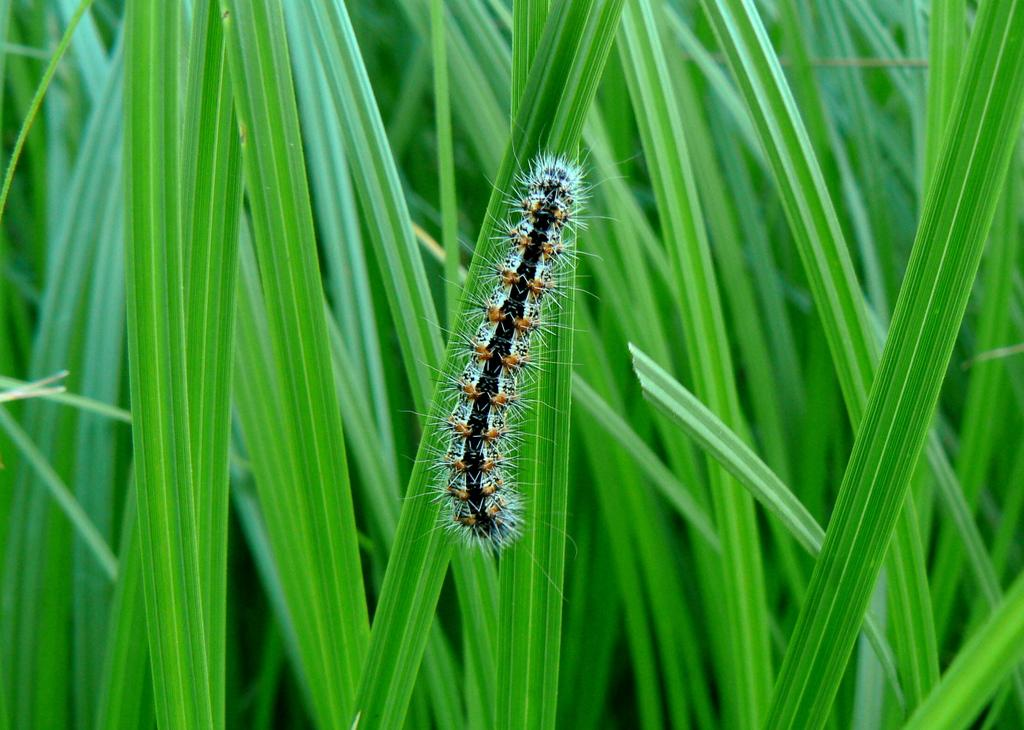What is on the leaf in the image? There is an insect on a leaf in the image. What else can be seen in the image besides the insect? There are plants in the image. Where is the harbor located in the image? There is no harbor present in the image. What type of receipt can be seen in the image? There is no receipt present in the image. 